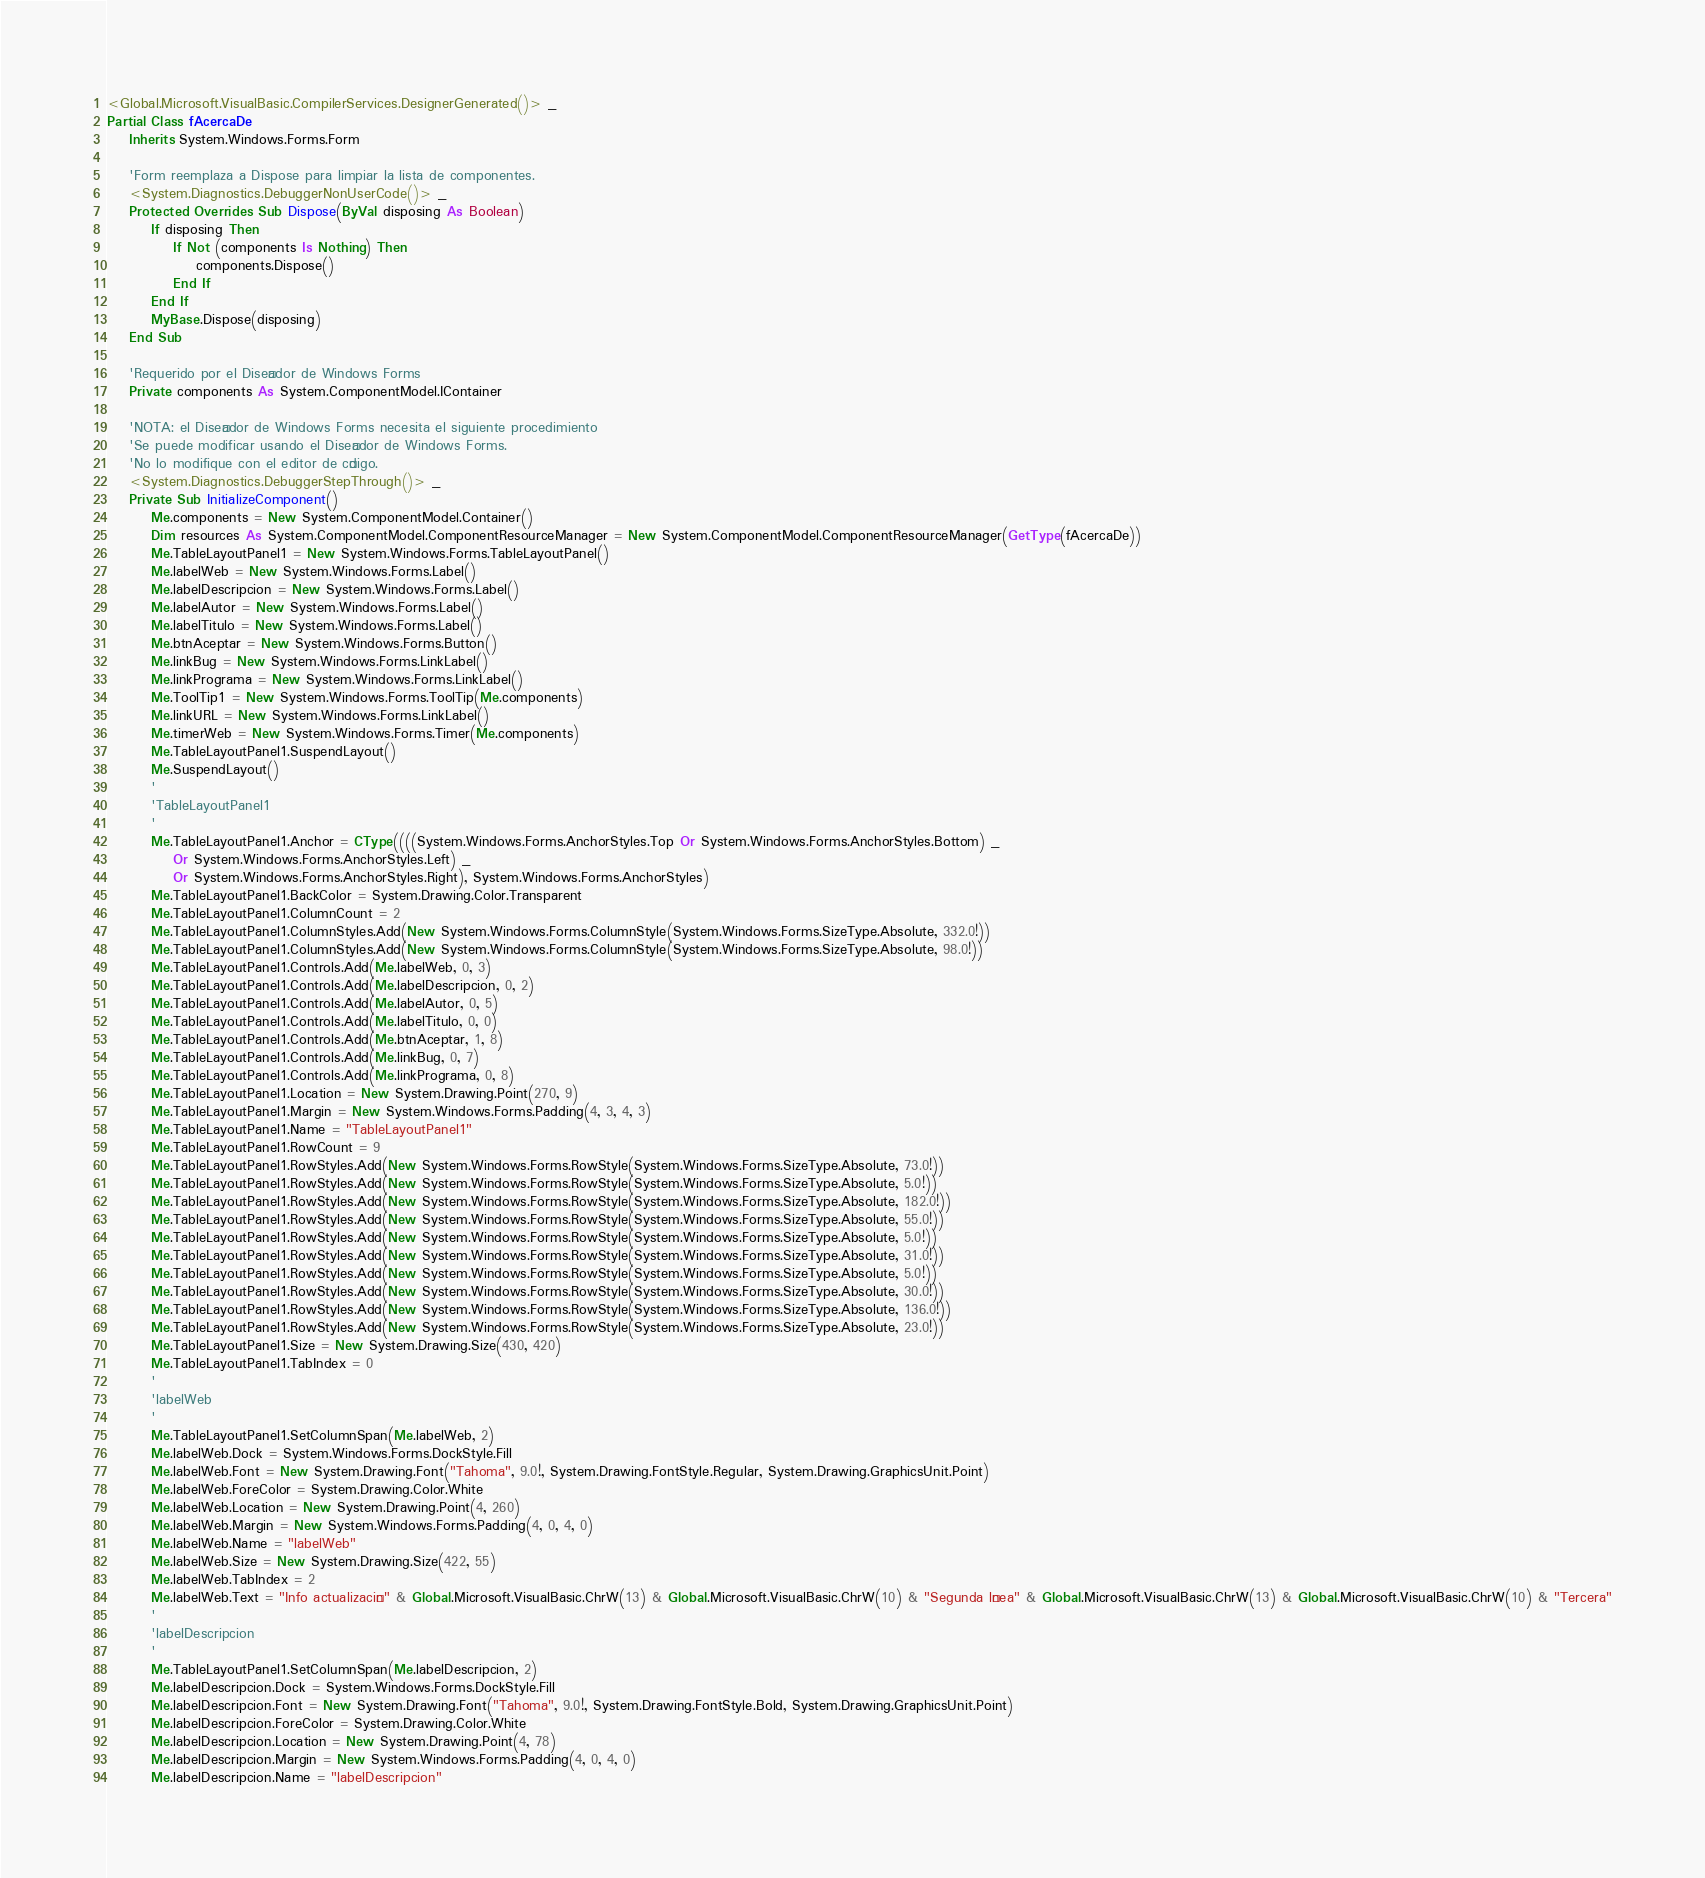Convert code to text. <code><loc_0><loc_0><loc_500><loc_500><_VisualBasic_><Global.Microsoft.VisualBasic.CompilerServices.DesignerGenerated()> _
Partial Class fAcercaDe
    Inherits System.Windows.Forms.Form

    'Form reemplaza a Dispose para limpiar la lista de componentes.
    <System.Diagnostics.DebuggerNonUserCode()> _
    Protected Overrides Sub Dispose(ByVal disposing As Boolean)
        If disposing Then
            If Not (components Is Nothing) Then
                components.Dispose()
            End If
        End If
        MyBase.Dispose(disposing)
    End Sub

    'Requerido por el Diseñador de Windows Forms
    Private components As System.ComponentModel.IContainer

    'NOTA: el Diseñador de Windows Forms necesita el siguiente procedimiento
    'Se puede modificar usando el Diseñador de Windows Forms.  
    'No lo modifique con el editor de código.
    <System.Diagnostics.DebuggerStepThrough()> _
    Private Sub InitializeComponent()
        Me.components = New System.ComponentModel.Container()
        Dim resources As System.ComponentModel.ComponentResourceManager = New System.ComponentModel.ComponentResourceManager(GetType(fAcercaDe))
        Me.TableLayoutPanel1 = New System.Windows.Forms.TableLayoutPanel()
        Me.labelWeb = New System.Windows.Forms.Label()
        Me.labelDescripcion = New System.Windows.Forms.Label()
        Me.labelAutor = New System.Windows.Forms.Label()
        Me.labelTitulo = New System.Windows.Forms.Label()
        Me.btnAceptar = New System.Windows.Forms.Button()
        Me.linkBug = New System.Windows.Forms.LinkLabel()
        Me.linkPrograma = New System.Windows.Forms.LinkLabel()
        Me.ToolTip1 = New System.Windows.Forms.ToolTip(Me.components)
        Me.linkURL = New System.Windows.Forms.LinkLabel()
        Me.timerWeb = New System.Windows.Forms.Timer(Me.components)
        Me.TableLayoutPanel1.SuspendLayout()
        Me.SuspendLayout()
        '
        'TableLayoutPanel1
        '
        Me.TableLayoutPanel1.Anchor = CType((((System.Windows.Forms.AnchorStyles.Top Or System.Windows.Forms.AnchorStyles.Bottom) _
            Or System.Windows.Forms.AnchorStyles.Left) _
            Or System.Windows.Forms.AnchorStyles.Right), System.Windows.Forms.AnchorStyles)
        Me.TableLayoutPanel1.BackColor = System.Drawing.Color.Transparent
        Me.TableLayoutPanel1.ColumnCount = 2
        Me.TableLayoutPanel1.ColumnStyles.Add(New System.Windows.Forms.ColumnStyle(System.Windows.Forms.SizeType.Absolute, 332.0!))
        Me.TableLayoutPanel1.ColumnStyles.Add(New System.Windows.Forms.ColumnStyle(System.Windows.Forms.SizeType.Absolute, 98.0!))
        Me.TableLayoutPanel1.Controls.Add(Me.labelWeb, 0, 3)
        Me.TableLayoutPanel1.Controls.Add(Me.labelDescripcion, 0, 2)
        Me.TableLayoutPanel1.Controls.Add(Me.labelAutor, 0, 5)
        Me.TableLayoutPanel1.Controls.Add(Me.labelTitulo, 0, 0)
        Me.TableLayoutPanel1.Controls.Add(Me.btnAceptar, 1, 8)
        Me.TableLayoutPanel1.Controls.Add(Me.linkBug, 0, 7)
        Me.TableLayoutPanel1.Controls.Add(Me.linkPrograma, 0, 8)
        Me.TableLayoutPanel1.Location = New System.Drawing.Point(270, 9)
        Me.TableLayoutPanel1.Margin = New System.Windows.Forms.Padding(4, 3, 4, 3)
        Me.TableLayoutPanel1.Name = "TableLayoutPanel1"
        Me.TableLayoutPanel1.RowCount = 9
        Me.TableLayoutPanel1.RowStyles.Add(New System.Windows.Forms.RowStyle(System.Windows.Forms.SizeType.Absolute, 73.0!))
        Me.TableLayoutPanel1.RowStyles.Add(New System.Windows.Forms.RowStyle(System.Windows.Forms.SizeType.Absolute, 5.0!))
        Me.TableLayoutPanel1.RowStyles.Add(New System.Windows.Forms.RowStyle(System.Windows.Forms.SizeType.Absolute, 182.0!))
        Me.TableLayoutPanel1.RowStyles.Add(New System.Windows.Forms.RowStyle(System.Windows.Forms.SizeType.Absolute, 55.0!))
        Me.TableLayoutPanel1.RowStyles.Add(New System.Windows.Forms.RowStyle(System.Windows.Forms.SizeType.Absolute, 5.0!))
        Me.TableLayoutPanel1.RowStyles.Add(New System.Windows.Forms.RowStyle(System.Windows.Forms.SizeType.Absolute, 31.0!))
        Me.TableLayoutPanel1.RowStyles.Add(New System.Windows.Forms.RowStyle(System.Windows.Forms.SizeType.Absolute, 5.0!))
        Me.TableLayoutPanel1.RowStyles.Add(New System.Windows.Forms.RowStyle(System.Windows.Forms.SizeType.Absolute, 30.0!))
        Me.TableLayoutPanel1.RowStyles.Add(New System.Windows.Forms.RowStyle(System.Windows.Forms.SizeType.Absolute, 136.0!))
        Me.TableLayoutPanel1.RowStyles.Add(New System.Windows.Forms.RowStyle(System.Windows.Forms.SizeType.Absolute, 23.0!))
        Me.TableLayoutPanel1.Size = New System.Drawing.Size(430, 420)
        Me.TableLayoutPanel1.TabIndex = 0
        '
        'labelWeb
        '
        Me.TableLayoutPanel1.SetColumnSpan(Me.labelWeb, 2)
        Me.labelWeb.Dock = System.Windows.Forms.DockStyle.Fill
        Me.labelWeb.Font = New System.Drawing.Font("Tahoma", 9.0!, System.Drawing.FontStyle.Regular, System.Drawing.GraphicsUnit.Point)
        Me.labelWeb.ForeColor = System.Drawing.Color.White
        Me.labelWeb.Location = New System.Drawing.Point(4, 260)
        Me.labelWeb.Margin = New System.Windows.Forms.Padding(4, 0, 4, 0)
        Me.labelWeb.Name = "labelWeb"
        Me.labelWeb.Size = New System.Drawing.Size(422, 55)
        Me.labelWeb.TabIndex = 2
        Me.labelWeb.Text = "Info actualización" & Global.Microsoft.VisualBasic.ChrW(13) & Global.Microsoft.VisualBasic.ChrW(10) & "Segunda línea" & Global.Microsoft.VisualBasic.ChrW(13) & Global.Microsoft.VisualBasic.ChrW(10) & "Tercera"
        '
        'labelDescripcion
        '
        Me.TableLayoutPanel1.SetColumnSpan(Me.labelDescripcion, 2)
        Me.labelDescripcion.Dock = System.Windows.Forms.DockStyle.Fill
        Me.labelDescripcion.Font = New System.Drawing.Font("Tahoma", 9.0!, System.Drawing.FontStyle.Bold, System.Drawing.GraphicsUnit.Point)
        Me.labelDescripcion.ForeColor = System.Drawing.Color.White
        Me.labelDescripcion.Location = New System.Drawing.Point(4, 78)
        Me.labelDescripcion.Margin = New System.Windows.Forms.Padding(4, 0, 4, 0)
        Me.labelDescripcion.Name = "labelDescripcion"</code> 